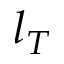Convert formula to latex. <formula><loc_0><loc_0><loc_500><loc_500>l _ { T }</formula> 